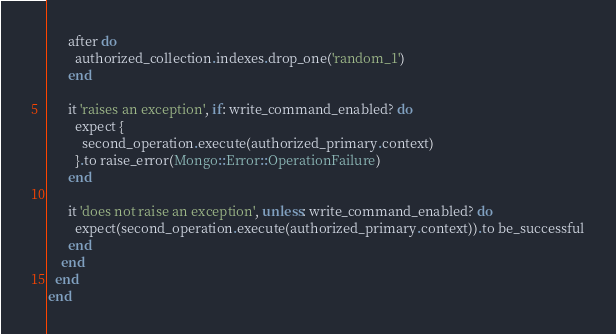Convert code to text. <code><loc_0><loc_0><loc_500><loc_500><_Ruby_>      after do
        authorized_collection.indexes.drop_one('random_1')
      end

      it 'raises an exception', if: write_command_enabled? do
        expect {
          second_operation.execute(authorized_primary.context)
        }.to raise_error(Mongo::Error::OperationFailure)
      end

      it 'does not raise an exception', unless: write_command_enabled? do
        expect(second_operation.execute(authorized_primary.context)).to be_successful
      end
    end
  end
end
</code> 